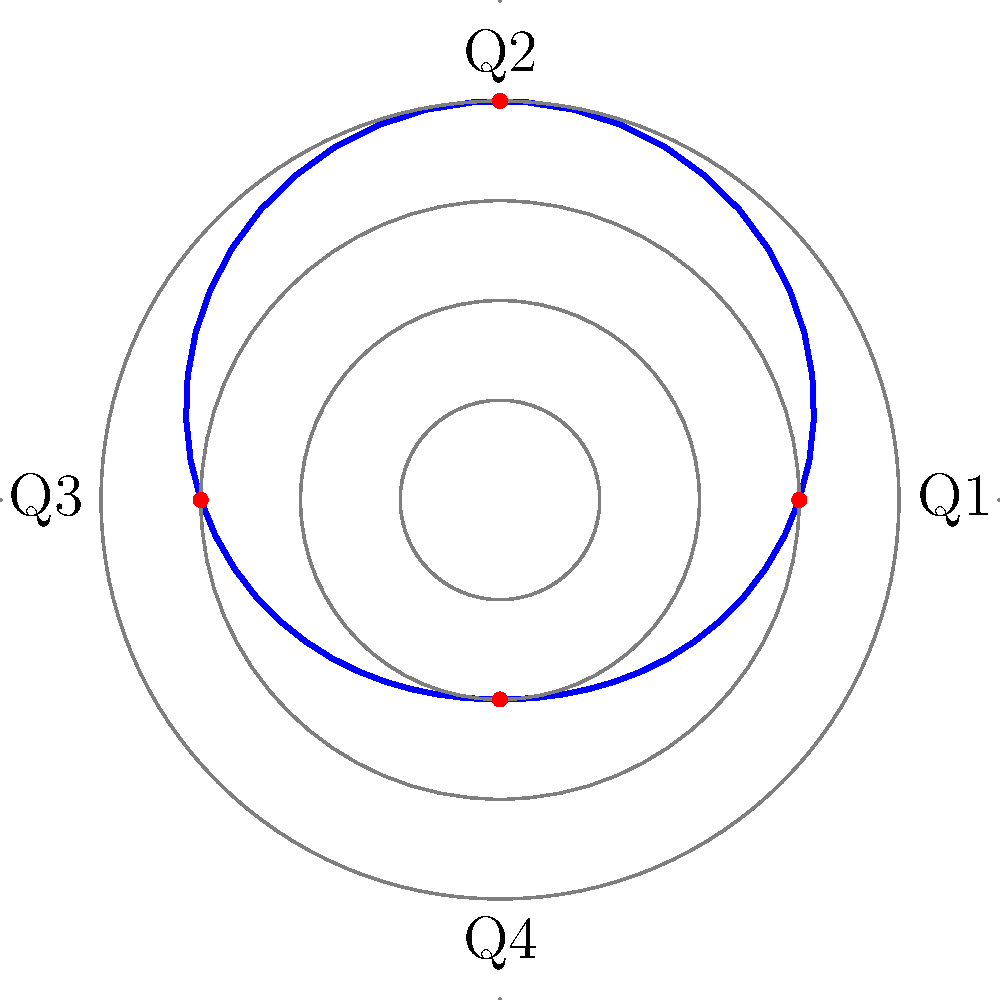As a government official, you've been tasked with presenting approval ratings data to international media. The spiral plot above shows quarterly approval ratings over a year. Which quarter demonstrates the most favorable trend for highlighting the administration's success? To determine the most favorable quarter for highlighting the administration's success, we need to analyze the spiral plot:

1. The plot represents approval ratings over four quarters (Q1 to Q4).
2. The distance from the center indicates the approval rating percentage.
3. The spiral moves clockwise, starting from the positive x-axis (Q1) and ending near the center (Q4).

Analyzing each quarter:
- Q1 (right): Starts high but shows a slight decline.
- Q2 (top): Begins lower than Q1 but shows an increasing trend.
- Q3 (left): Starts at a similar level to Q2 end, but declines.
- Q4 (bottom): Begins at the lowest point but shows a sharp increase.

From a government official's perspective aiming to downplay any negative trends:
1. Q1's slight decline can be ignored, focusing on the high starting point.
2. Q2's upward trend is positive but starts lower than desired.
3. Q3's decline is not ideal for presentation.
4. Q4 shows the most dramatic improvement, which can be emphasized as a strong positive trend, despite starting at the lowest point.

Given the persona's preference to downplay severity and highlight successes, Q4 provides the most compelling narrative of improvement and positive momentum.
Answer: Q4 